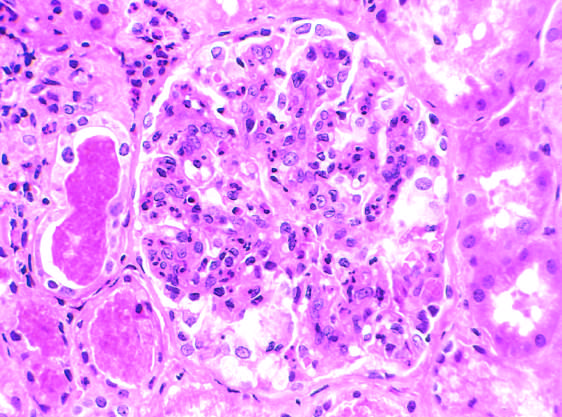s glomerular hypercellularity caused by intracapillary leukocytes and proliferation of intrinsic glomerular cells?
Answer the question using a single word or phrase. Yes 